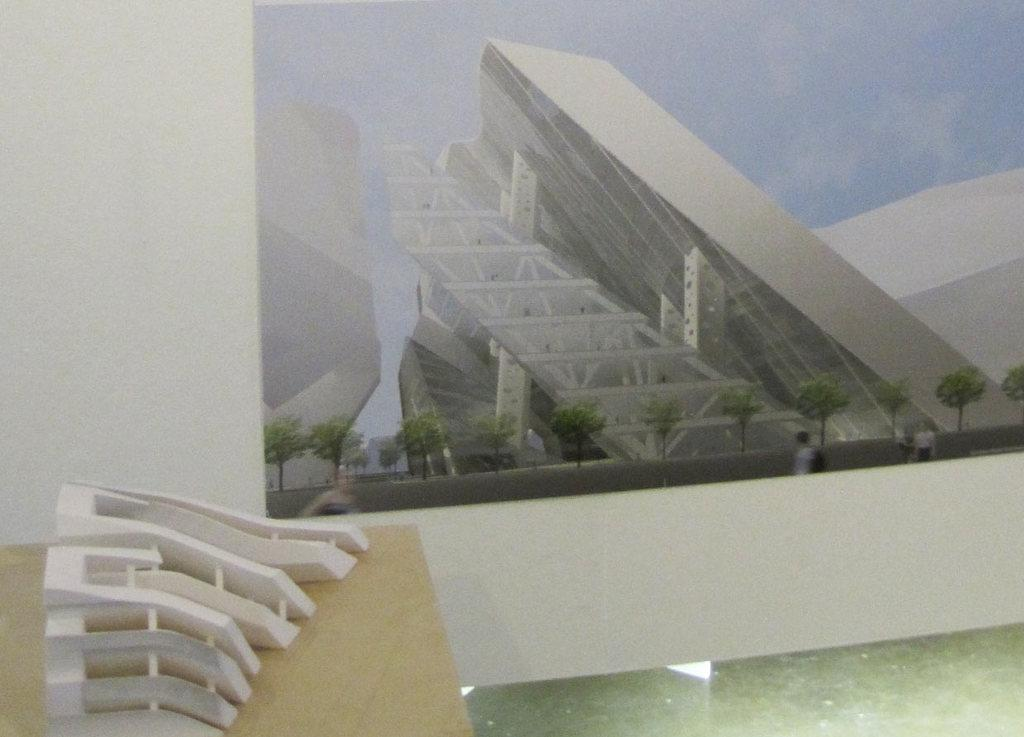What type of structures can be seen in the image? There are buildings in the image. What other natural elements are present in the image? There are trees in the image. Can you describe the people in the image? People are visible on a path in the image. What object is on the table in the image? There is a white object on a table in the image. What type of muscle is visible in the image? There is no muscle visible in the image. How many parcels can be seen in the image? There is no parcel present in the image. 